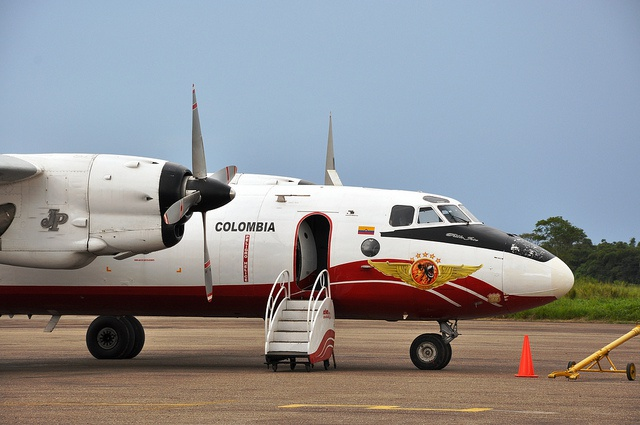Describe the objects in this image and their specific colors. I can see airplane in darkgray, black, lightgray, and maroon tones and airplane in darkgray, lightgray, gray, and black tones in this image. 